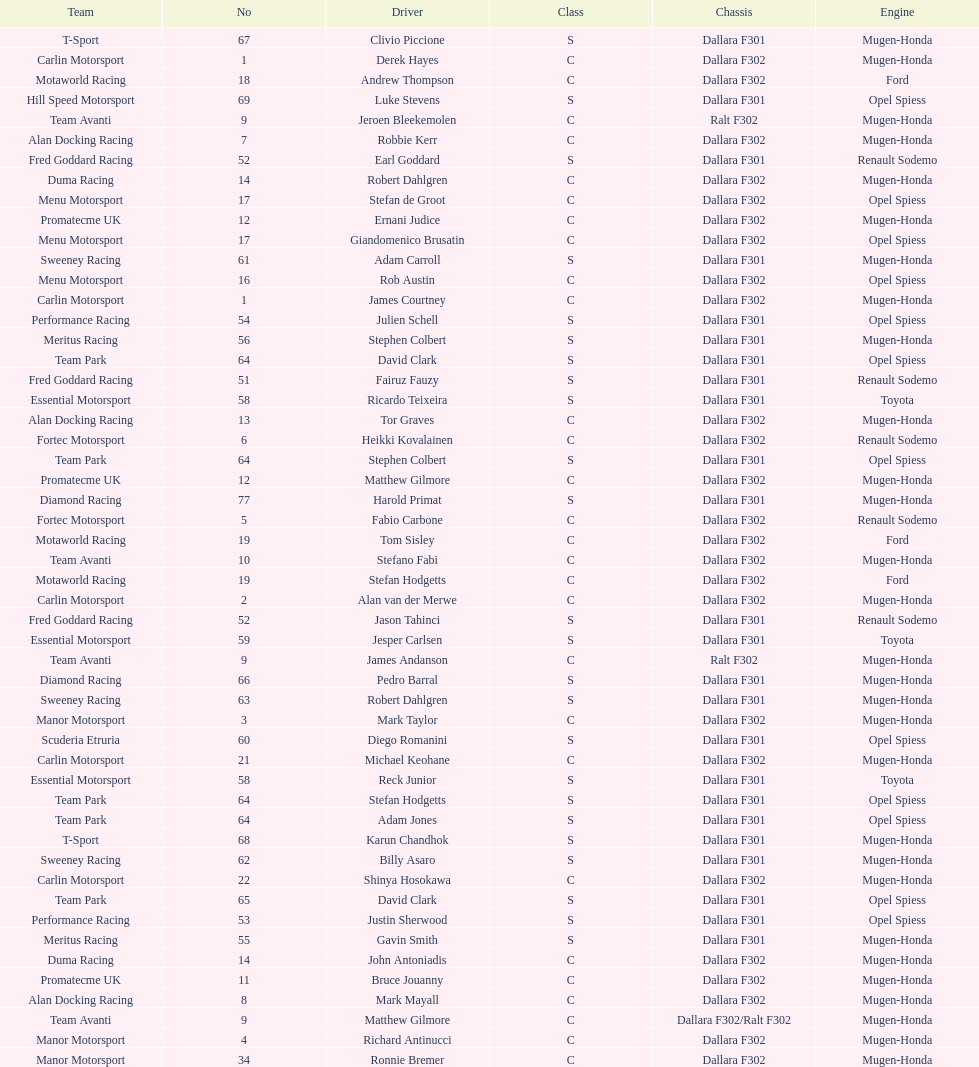The two drivers on t-sport are clivio piccione and what other driver? Karun Chandhok. 